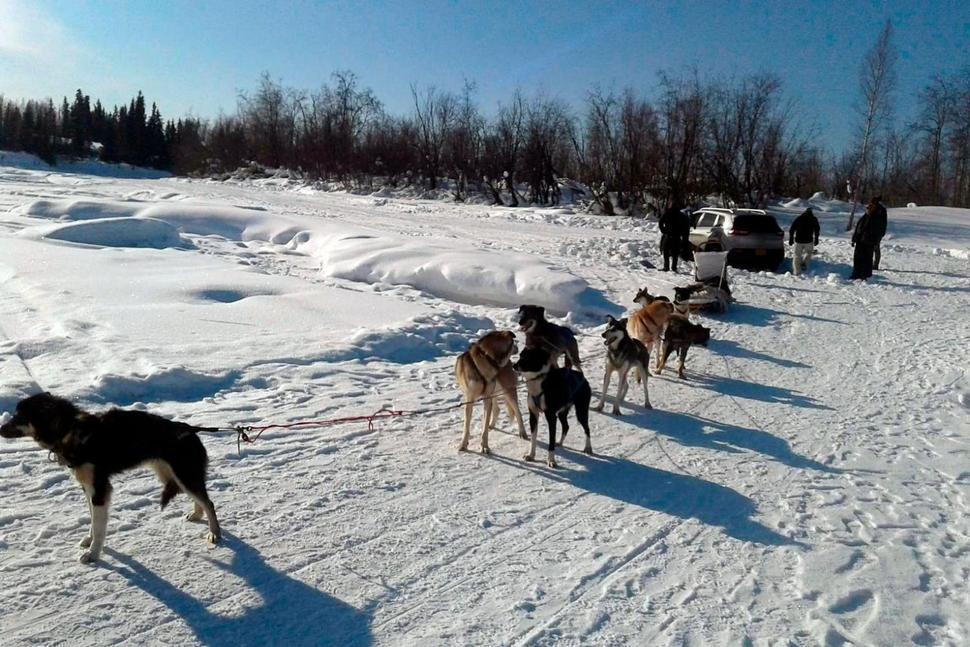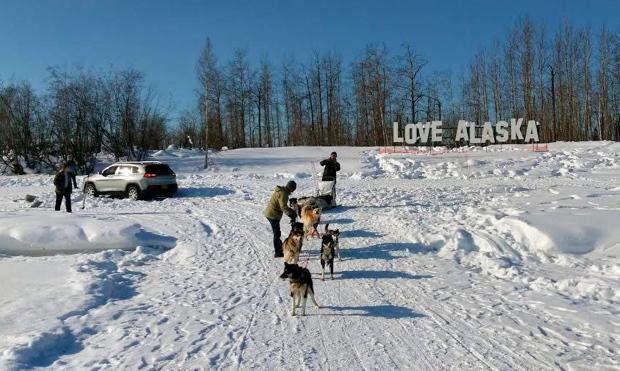The first image is the image on the left, the second image is the image on the right. Given the left and right images, does the statement "The exterior of a motorized vehicle is visible behind sled dogs in at least one image." hold true? Answer yes or no. Yes. The first image is the image on the left, the second image is the image on the right. Evaluate the accuracy of this statement regarding the images: "An SUV can be seen in the background on at least one of the images.". Is it true? Answer yes or no. Yes. 